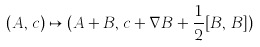<formula> <loc_0><loc_0><loc_500><loc_500>( A , \, c ) \mapsto ( A + B , \, c + { \nabla } B + { \frac { 1 } { 2 } } [ B , \, B ] )</formula> 